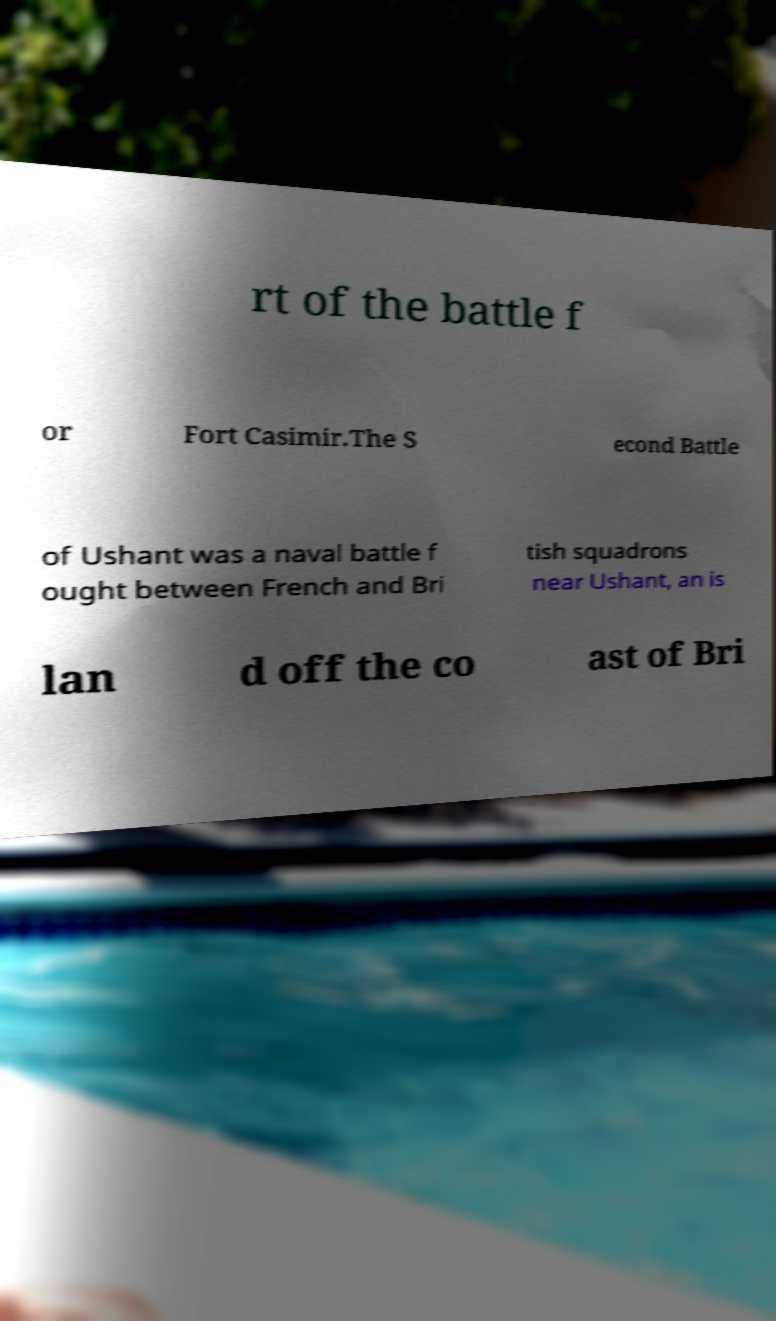There's text embedded in this image that I need extracted. Can you transcribe it verbatim? rt of the battle f or Fort Casimir.The S econd Battle of Ushant was a naval battle f ought between French and Bri tish squadrons near Ushant, an is lan d off the co ast of Bri 